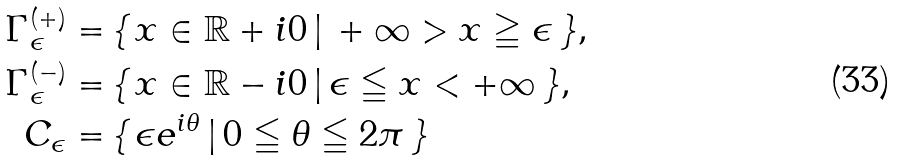<formula> <loc_0><loc_0><loc_500><loc_500>\Gamma _ { \epsilon } ^ { ( + ) } = \, & \{ \, x \in \mathbb { R } + i 0 \, | \, + \infty > x \geqq \epsilon \, \} , \\ \Gamma _ { \epsilon } ^ { ( - ) } = \, & \{ \, x \in \mathbb { R } - i 0 \, | \, \epsilon \leqq x < + \infty \, \} , \\ C _ { \epsilon } = \, & \{ \, \epsilon e ^ { i \theta } \, | \, 0 \leqq \theta \leqq 2 \pi \, \}</formula> 